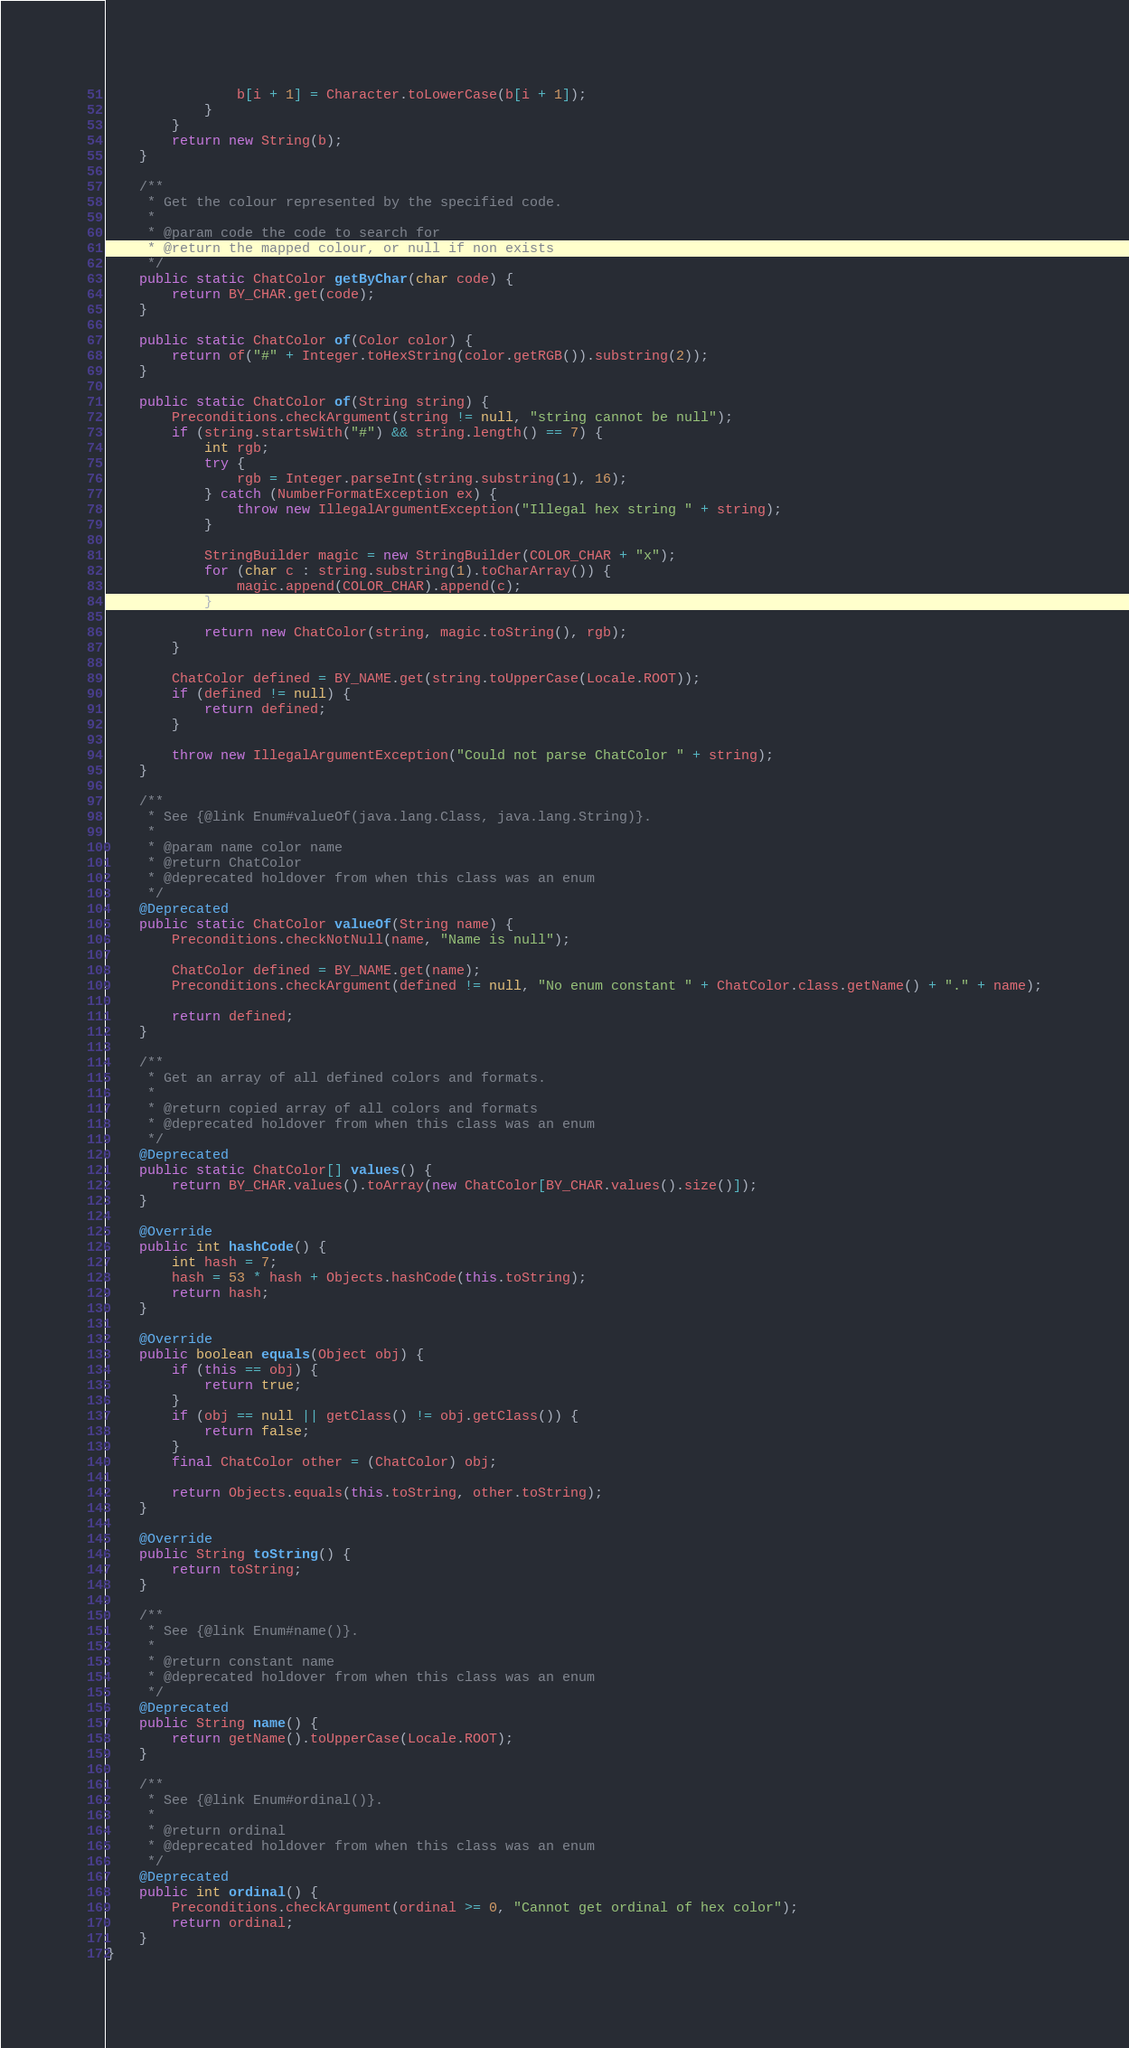Convert code to text. <code><loc_0><loc_0><loc_500><loc_500><_Java_>                b[i + 1] = Character.toLowerCase(b[i + 1]);
            }
        }
        return new String(b);
    }

    /**
     * Get the colour represented by the specified code.
     *
     * @param code the code to search for
     * @return the mapped colour, or null if non exists
     */
    public static ChatColor getByChar(char code) {
        return BY_CHAR.get(code);
    }

    public static ChatColor of(Color color) {
        return of("#" + Integer.toHexString(color.getRGB()).substring(2));
    }

    public static ChatColor of(String string) {
        Preconditions.checkArgument(string != null, "string cannot be null");
        if (string.startsWith("#") && string.length() == 7) {
            int rgb;
            try {
                rgb = Integer.parseInt(string.substring(1), 16);
            } catch (NumberFormatException ex) {
                throw new IllegalArgumentException("Illegal hex string " + string);
            }

            StringBuilder magic = new StringBuilder(COLOR_CHAR + "x");
            for (char c : string.substring(1).toCharArray()) {
                magic.append(COLOR_CHAR).append(c);
            }

            return new ChatColor(string, magic.toString(), rgb);
        }

        ChatColor defined = BY_NAME.get(string.toUpperCase(Locale.ROOT));
        if (defined != null) {
            return defined;
        }

        throw new IllegalArgumentException("Could not parse ChatColor " + string);
    }

    /**
     * See {@link Enum#valueOf(java.lang.Class, java.lang.String)}.
     *
     * @param name color name
     * @return ChatColor
     * @deprecated holdover from when this class was an enum
     */
    @Deprecated
    public static ChatColor valueOf(String name) {
        Preconditions.checkNotNull(name, "Name is null");

        ChatColor defined = BY_NAME.get(name);
        Preconditions.checkArgument(defined != null, "No enum constant " + ChatColor.class.getName() + "." + name);

        return defined;
    }

    /**
     * Get an array of all defined colors and formats.
     *
     * @return copied array of all colors and formats
     * @deprecated holdover from when this class was an enum
     */
    @Deprecated
    public static ChatColor[] values() {
        return BY_CHAR.values().toArray(new ChatColor[BY_CHAR.values().size()]);
    }

    @Override
    public int hashCode() {
        int hash = 7;
        hash = 53 * hash + Objects.hashCode(this.toString);
        return hash;
    }

    @Override
    public boolean equals(Object obj) {
        if (this == obj) {
            return true;
        }
        if (obj == null || getClass() != obj.getClass()) {
            return false;
        }
        final ChatColor other = (ChatColor) obj;

        return Objects.equals(this.toString, other.toString);
    }

    @Override
    public String toString() {
        return toString;
    }

    /**
     * See {@link Enum#name()}.
     *
     * @return constant name
     * @deprecated holdover from when this class was an enum
     */
    @Deprecated
    public String name() {
        return getName().toUpperCase(Locale.ROOT);
    }

    /**
     * See {@link Enum#ordinal()}.
     *
     * @return ordinal
     * @deprecated holdover from when this class was an enum
     */
    @Deprecated
    public int ordinal() {
        Preconditions.checkArgument(ordinal >= 0, "Cannot get ordinal of hex color");
        return ordinal;
    }
}
</code> 